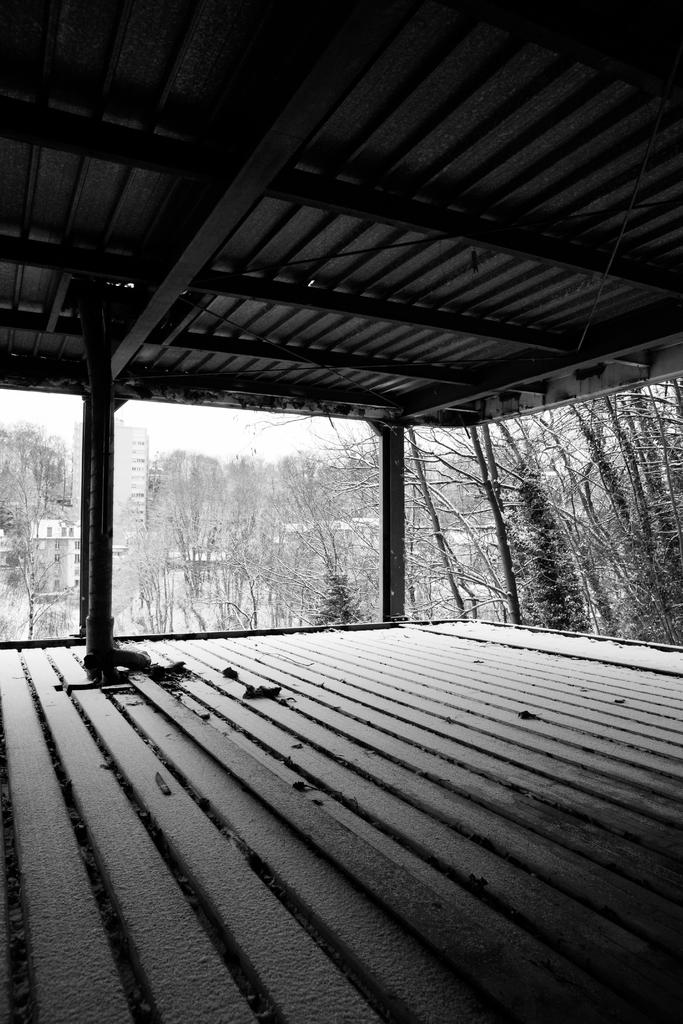What is the color scheme of the image? The image is black and white. What type of natural elements can be seen in the image? There are trees in the image. What is visible at the top of the image? There is a ceiling visible at the top of the image. What is visible at the bottom of the image? There is a floor visible at the bottom of the image. What architectural features are present in the image? There are pillars in the image. Where is the nest located in the image? There is no nest present in the image. What type of cake is being served in the image? There is no cake present in the image. 